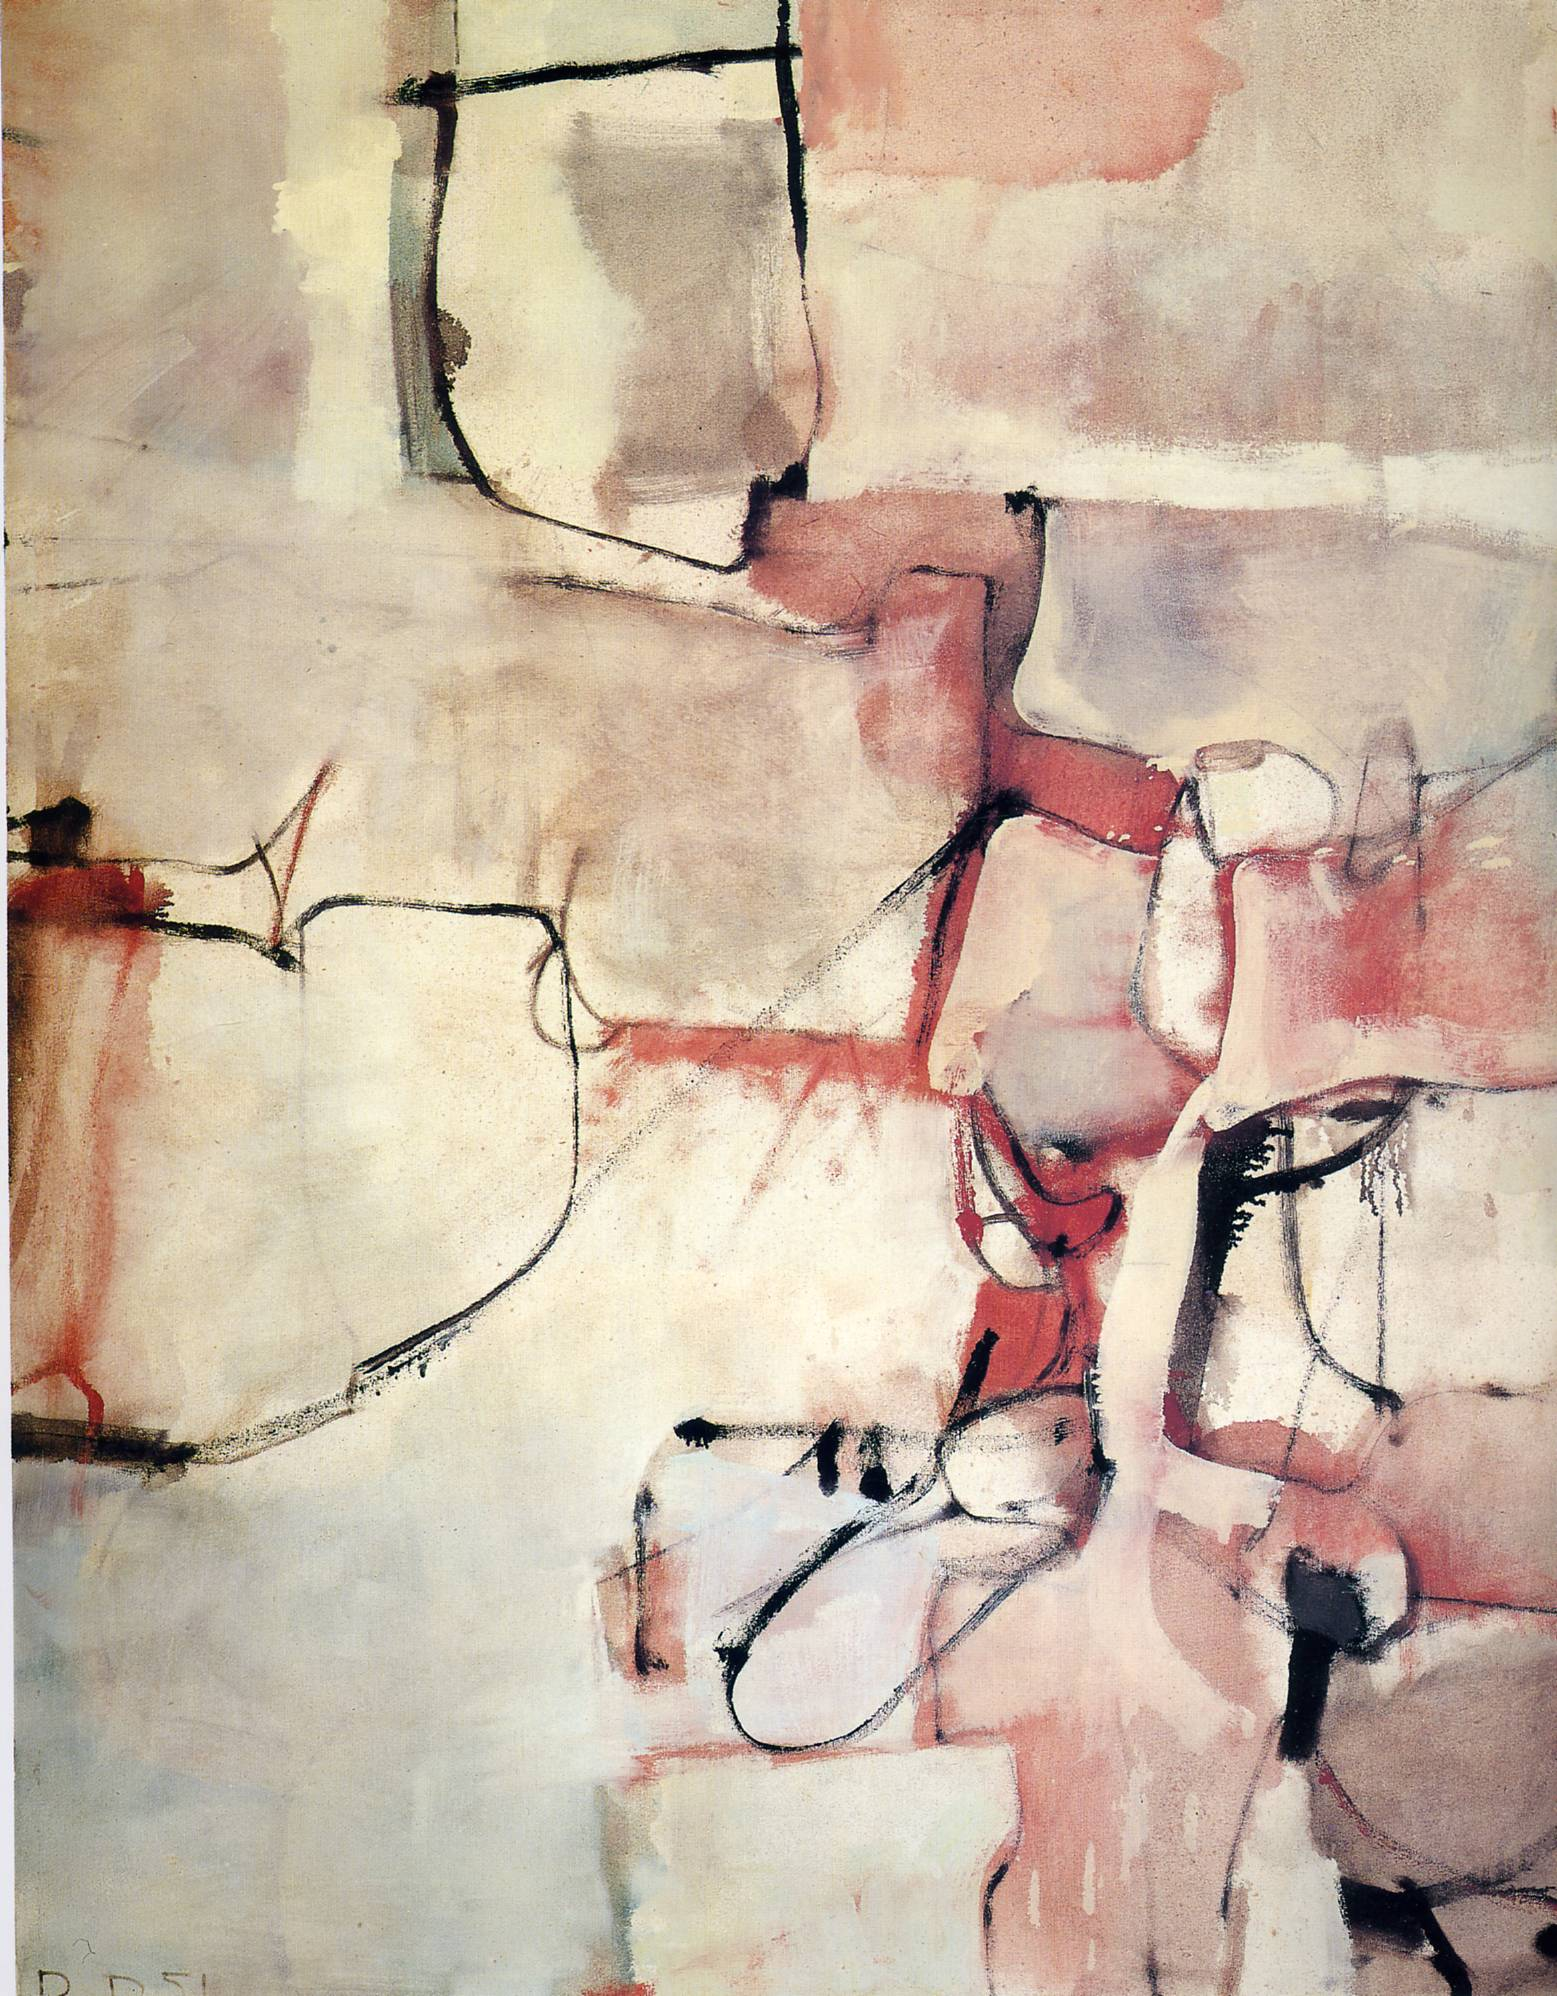What kind of setting might this artwork fit into? This artwork would be a stunning addition to a modern, minimalistic space, possibly in a contemporary art gallery or a sophisticated living room. Its abstract nature and warm color palette would bring a sense of elegance and intrigue to the setting, inviting viewers to pause and reflect. It could also fit beautifully in a creative workspace, inspiring thought and fostering an atmosphere of creativity and expression. Could this artwork invoke any specific memories or imaginations? Absolutely. The abstract forms and warm colors might evoke memories of a tranquil sunset, with its soft, fading light and the intricate play of shadows and colors. It could also stir up imaginations of a bustling cityscape viewed through a fogged window, blurring and merging in the mind into something almost dreamlike. The fluidity and open-ended nature of the piece allow for personal interpretations and emotional connections. What kind of cultural influence do you observe in this artwork? The artwork suggests influence from mid-20th-century abstract expressionism, a movement heavily rooted in American post-war cultural expression and emotional depth. The cubist elements point towards early 20th-century European modernist movements, likely influenced by artists like Picasso and Braque. This fusion of styles reflects a dialogue between different epochs and geographical artistic influences, creating a rich tapestry of cultural and emotional narratives. Can this painting inspire any written work, like a poem or a short story? Certainly! Imagine a poem inspired by the soft, warm hues and dynamic lines of the painting:

In hues of red and pink you spoke,
Of secrets held in soft beige cloak.
Lines bold, emotions winding tight,
In abstract whispers, day meets night.
Spaces blank, reflections pure,
A canvas of feelings, deep and sure.
From cubist dreams, your heart did pour,
In silent echoes, forevermore. 